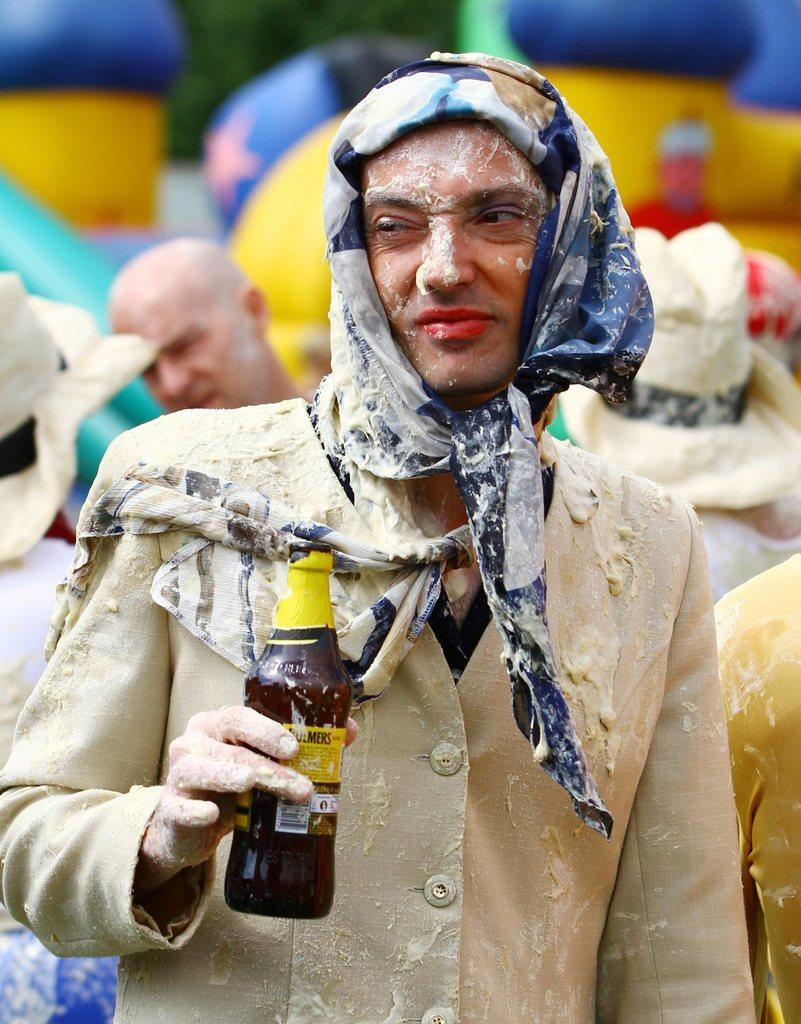Who is the main subject in the image? There is a man in the image. What is the man holding in the image? The man is holding a bottle. Can you describe the man's attire in the image? The man is wearing a scarf. Are there any other people visible in the image? Yes, there are people standing behind the man. What impulse does the sugar in the image have? There is no sugar present in the image, so it cannot have any impulses. What idea is the man trying to convey with the bottle in the image? The image does not provide any information about the man's intentions or ideas, so we cannot determine what he is trying to convey with the bottle. 